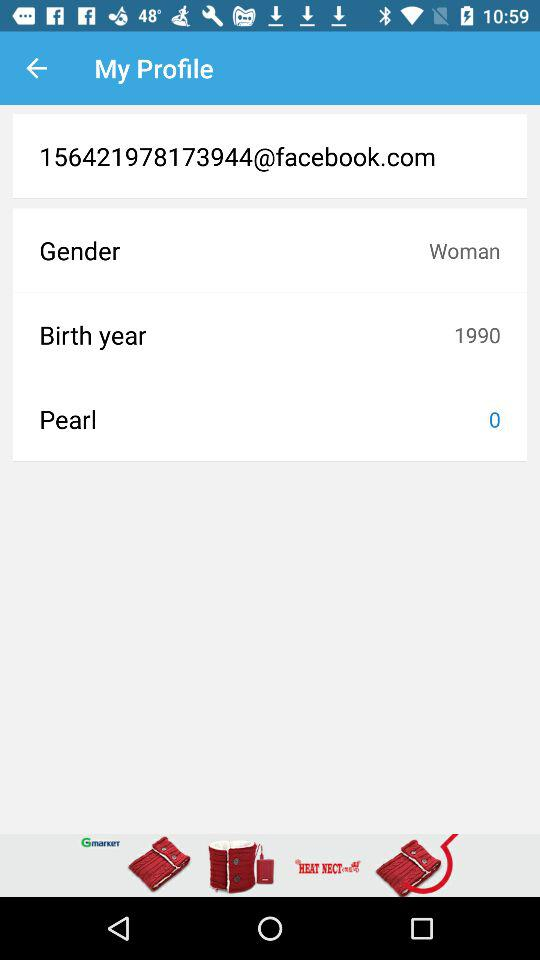How many pearls are shown here? There are zero pearls. 